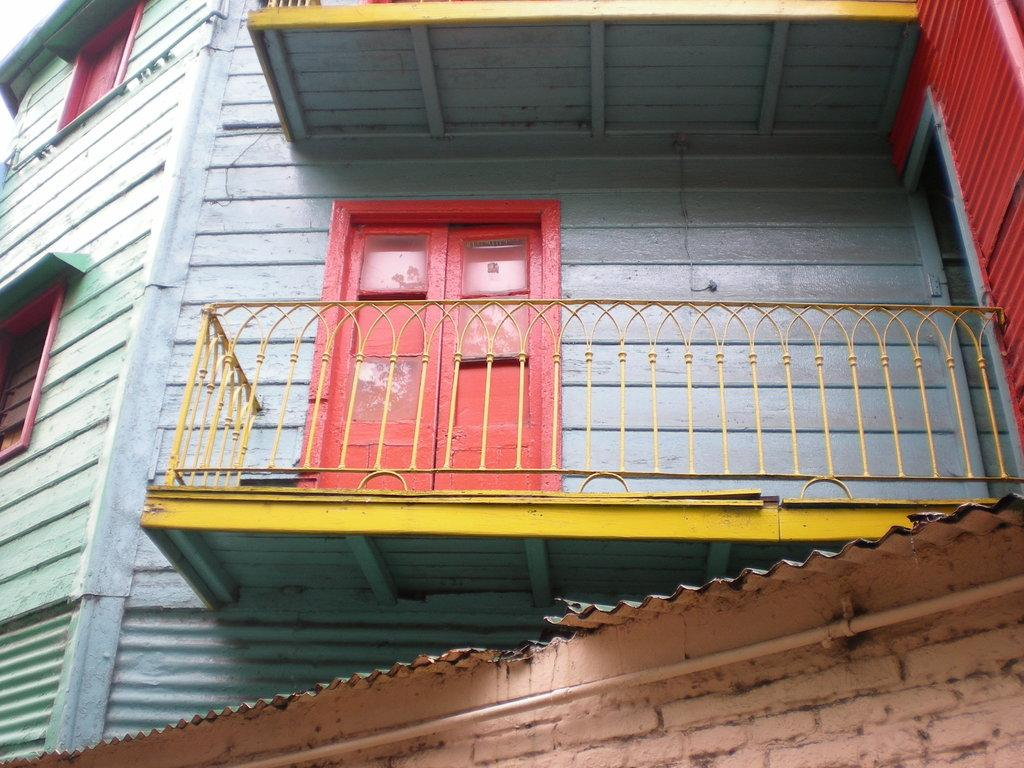Where was the image taken? The image is taken outdoors. What can be seen in the image besides the outdoor setting? There is a building in the image. Can you describe the building's features? The building has walls, windows, a door, a balcony, and railings. What type of activity is the slave performing on the balcony in the image? There is no slave or any activity involving a slave present in the image. 